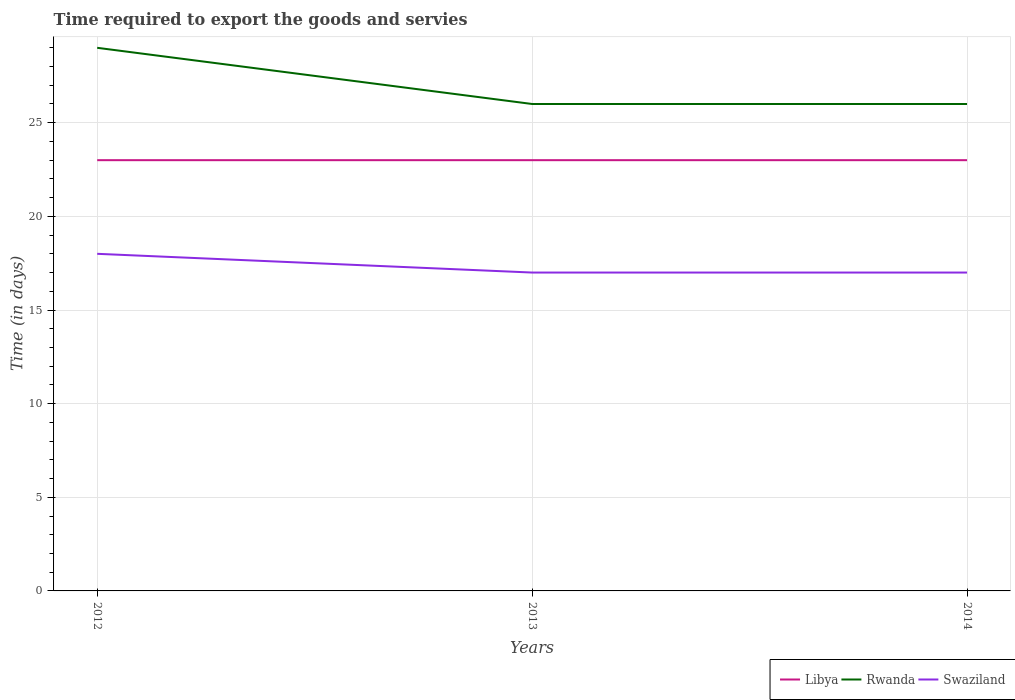Is the number of lines equal to the number of legend labels?
Your answer should be very brief. Yes. Across all years, what is the maximum number of days required to export the goods and services in Swaziland?
Your response must be concise. 17. What is the difference between two consecutive major ticks on the Y-axis?
Ensure brevity in your answer.  5. Does the graph contain grids?
Offer a terse response. Yes. Where does the legend appear in the graph?
Your answer should be compact. Bottom right. How are the legend labels stacked?
Provide a short and direct response. Horizontal. What is the title of the graph?
Your response must be concise. Time required to export the goods and servies. Does "Slovenia" appear as one of the legend labels in the graph?
Provide a short and direct response. No. What is the label or title of the X-axis?
Ensure brevity in your answer.  Years. What is the label or title of the Y-axis?
Your answer should be very brief. Time (in days). What is the Time (in days) of Libya in 2013?
Keep it short and to the point. 23. What is the Time (in days) of Rwanda in 2013?
Your response must be concise. 26. What is the Time (in days) of Swaziland in 2013?
Your response must be concise. 17. What is the Time (in days) in Swaziland in 2014?
Provide a succinct answer. 17. Across all years, what is the maximum Time (in days) in Rwanda?
Make the answer very short. 29. Across all years, what is the minimum Time (in days) of Libya?
Offer a very short reply. 23. Across all years, what is the minimum Time (in days) of Swaziland?
Your answer should be compact. 17. What is the total Time (in days) of Libya in the graph?
Make the answer very short. 69. What is the difference between the Time (in days) of Libya in 2012 and that in 2013?
Keep it short and to the point. 0. What is the difference between the Time (in days) of Libya in 2012 and that in 2014?
Your answer should be compact. 0. What is the difference between the Time (in days) of Libya in 2013 and that in 2014?
Your answer should be compact. 0. What is the difference between the Time (in days) in Rwanda in 2013 and that in 2014?
Give a very brief answer. 0. What is the difference between the Time (in days) in Swaziland in 2013 and that in 2014?
Provide a succinct answer. 0. What is the difference between the Time (in days) of Libya in 2012 and the Time (in days) of Rwanda in 2013?
Your answer should be very brief. -3. What is the difference between the Time (in days) in Libya in 2012 and the Time (in days) in Swaziland in 2013?
Offer a very short reply. 6. What is the difference between the Time (in days) of Libya in 2013 and the Time (in days) of Swaziland in 2014?
Give a very brief answer. 6. What is the difference between the Time (in days) of Rwanda in 2013 and the Time (in days) of Swaziland in 2014?
Your answer should be compact. 9. What is the average Time (in days) of Libya per year?
Offer a terse response. 23. What is the average Time (in days) of Swaziland per year?
Offer a very short reply. 17.33. In the year 2012, what is the difference between the Time (in days) in Libya and Time (in days) in Rwanda?
Offer a very short reply. -6. In the year 2013, what is the difference between the Time (in days) in Rwanda and Time (in days) in Swaziland?
Ensure brevity in your answer.  9. In the year 2014, what is the difference between the Time (in days) of Libya and Time (in days) of Rwanda?
Give a very brief answer. -3. In the year 2014, what is the difference between the Time (in days) in Rwanda and Time (in days) in Swaziland?
Keep it short and to the point. 9. What is the ratio of the Time (in days) of Libya in 2012 to that in 2013?
Your answer should be compact. 1. What is the ratio of the Time (in days) in Rwanda in 2012 to that in 2013?
Keep it short and to the point. 1.12. What is the ratio of the Time (in days) of Swaziland in 2012 to that in 2013?
Offer a terse response. 1.06. What is the ratio of the Time (in days) of Libya in 2012 to that in 2014?
Give a very brief answer. 1. What is the ratio of the Time (in days) in Rwanda in 2012 to that in 2014?
Give a very brief answer. 1.12. What is the ratio of the Time (in days) in Swaziland in 2012 to that in 2014?
Make the answer very short. 1.06. What is the ratio of the Time (in days) in Swaziland in 2013 to that in 2014?
Your response must be concise. 1. What is the difference between the highest and the lowest Time (in days) in Libya?
Offer a very short reply. 0. What is the difference between the highest and the lowest Time (in days) of Rwanda?
Offer a terse response. 3. 